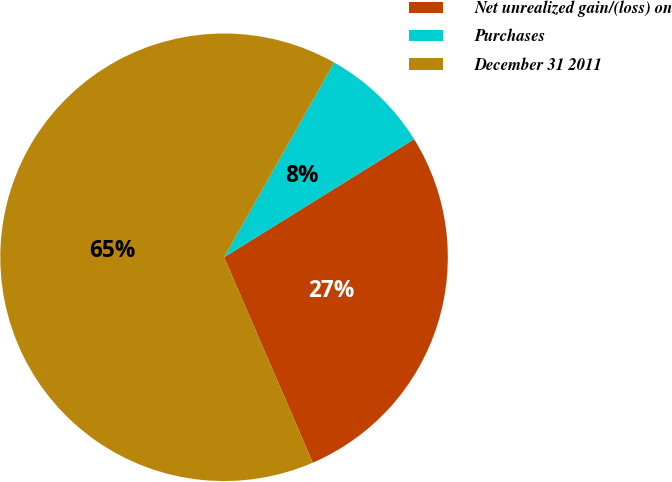Convert chart. <chart><loc_0><loc_0><loc_500><loc_500><pie_chart><fcel>Net unrealized gain/(loss) on<fcel>Purchases<fcel>December 31 2011<nl><fcel>27.36%<fcel>7.96%<fcel>64.68%<nl></chart> 